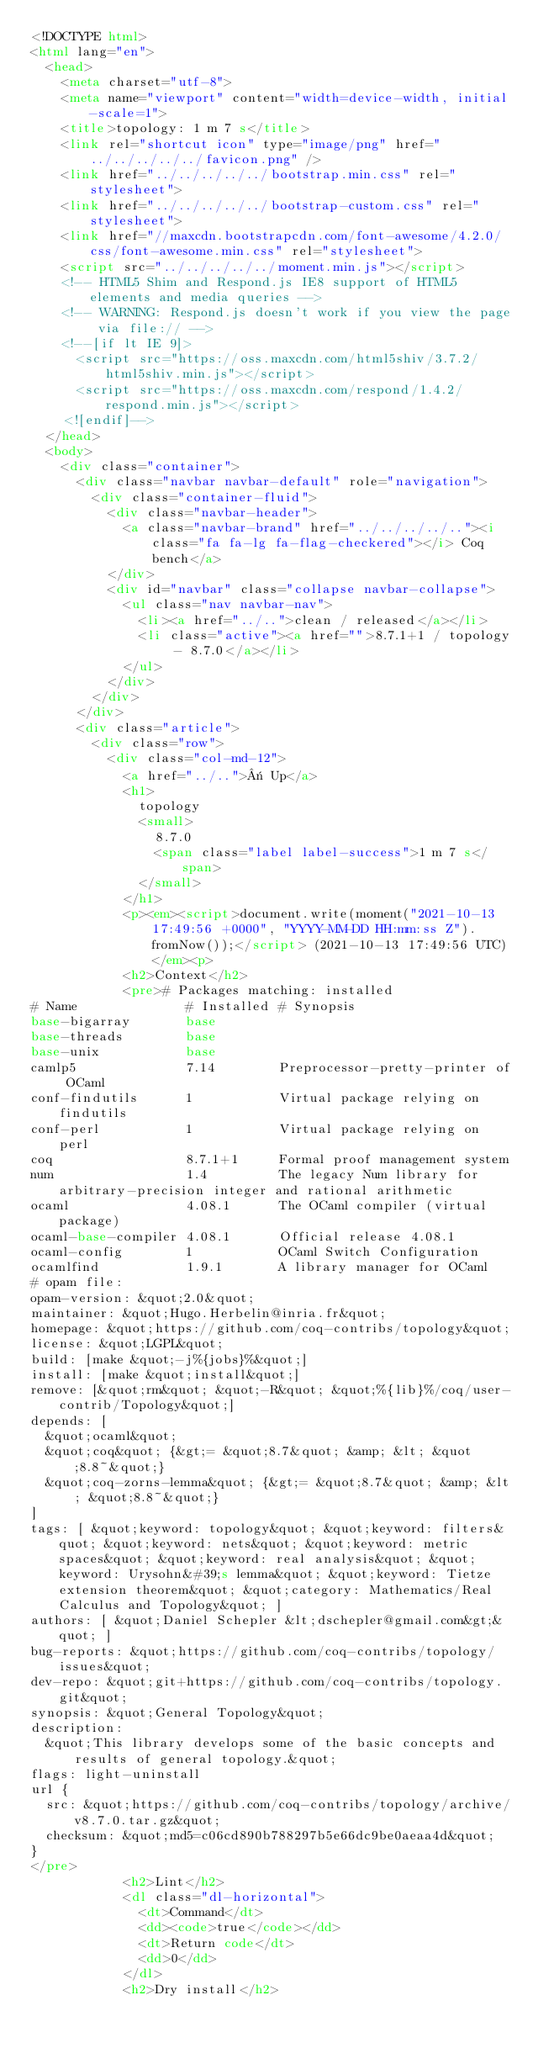<code> <loc_0><loc_0><loc_500><loc_500><_HTML_><!DOCTYPE html>
<html lang="en">
  <head>
    <meta charset="utf-8">
    <meta name="viewport" content="width=device-width, initial-scale=1">
    <title>topology: 1 m 7 s</title>
    <link rel="shortcut icon" type="image/png" href="../../../../../favicon.png" />
    <link href="../../../../../bootstrap.min.css" rel="stylesheet">
    <link href="../../../../../bootstrap-custom.css" rel="stylesheet">
    <link href="//maxcdn.bootstrapcdn.com/font-awesome/4.2.0/css/font-awesome.min.css" rel="stylesheet">
    <script src="../../../../../moment.min.js"></script>
    <!-- HTML5 Shim and Respond.js IE8 support of HTML5 elements and media queries -->
    <!-- WARNING: Respond.js doesn't work if you view the page via file:// -->
    <!--[if lt IE 9]>
      <script src="https://oss.maxcdn.com/html5shiv/3.7.2/html5shiv.min.js"></script>
      <script src="https://oss.maxcdn.com/respond/1.4.2/respond.min.js"></script>
    <![endif]-->
  </head>
  <body>
    <div class="container">
      <div class="navbar navbar-default" role="navigation">
        <div class="container-fluid">
          <div class="navbar-header">
            <a class="navbar-brand" href="../../../../.."><i class="fa fa-lg fa-flag-checkered"></i> Coq bench</a>
          </div>
          <div id="navbar" class="collapse navbar-collapse">
            <ul class="nav navbar-nav">
              <li><a href="../..">clean / released</a></li>
              <li class="active"><a href="">8.7.1+1 / topology - 8.7.0</a></li>
            </ul>
          </div>
        </div>
      </div>
      <div class="article">
        <div class="row">
          <div class="col-md-12">
            <a href="../..">« Up</a>
            <h1>
              topology
              <small>
                8.7.0
                <span class="label label-success">1 m 7 s</span>
              </small>
            </h1>
            <p><em><script>document.write(moment("2021-10-13 17:49:56 +0000", "YYYY-MM-DD HH:mm:ss Z").fromNow());</script> (2021-10-13 17:49:56 UTC)</em><p>
            <h2>Context</h2>
            <pre># Packages matching: installed
# Name              # Installed # Synopsis
base-bigarray       base
base-threads        base
base-unix           base
camlp5              7.14        Preprocessor-pretty-printer of OCaml
conf-findutils      1           Virtual package relying on findutils
conf-perl           1           Virtual package relying on perl
coq                 8.7.1+1     Formal proof management system
num                 1.4         The legacy Num library for arbitrary-precision integer and rational arithmetic
ocaml               4.08.1      The OCaml compiler (virtual package)
ocaml-base-compiler 4.08.1      Official release 4.08.1
ocaml-config        1           OCaml Switch Configuration
ocamlfind           1.9.1       A library manager for OCaml
# opam file:
opam-version: &quot;2.0&quot;
maintainer: &quot;Hugo.Herbelin@inria.fr&quot;
homepage: &quot;https://github.com/coq-contribs/topology&quot;
license: &quot;LGPL&quot;
build: [make &quot;-j%{jobs}%&quot;]
install: [make &quot;install&quot;]
remove: [&quot;rm&quot; &quot;-R&quot; &quot;%{lib}%/coq/user-contrib/Topology&quot;]
depends: [
  &quot;ocaml&quot;
  &quot;coq&quot; {&gt;= &quot;8.7&quot; &amp; &lt; &quot;8.8~&quot;}
  &quot;coq-zorns-lemma&quot; {&gt;= &quot;8.7&quot; &amp; &lt; &quot;8.8~&quot;}
]
tags: [ &quot;keyword: topology&quot; &quot;keyword: filters&quot; &quot;keyword: nets&quot; &quot;keyword: metric spaces&quot; &quot;keyword: real analysis&quot; &quot;keyword: Urysohn&#39;s lemma&quot; &quot;keyword: Tietze extension theorem&quot; &quot;category: Mathematics/Real Calculus and Topology&quot; ]
authors: [ &quot;Daniel Schepler &lt;dschepler@gmail.com&gt;&quot; ]
bug-reports: &quot;https://github.com/coq-contribs/topology/issues&quot;
dev-repo: &quot;git+https://github.com/coq-contribs/topology.git&quot;
synopsis: &quot;General Topology&quot;
description:
  &quot;This library develops some of the basic concepts and results of general topology.&quot;
flags: light-uninstall
url {
  src: &quot;https://github.com/coq-contribs/topology/archive/v8.7.0.tar.gz&quot;
  checksum: &quot;md5=c06cd890b788297b5e66dc9be0aeaa4d&quot;
}
</pre>
            <h2>Lint</h2>
            <dl class="dl-horizontal">
              <dt>Command</dt>
              <dd><code>true</code></dd>
              <dt>Return code</dt>
              <dd>0</dd>
            </dl>
            <h2>Dry install</h2></code> 